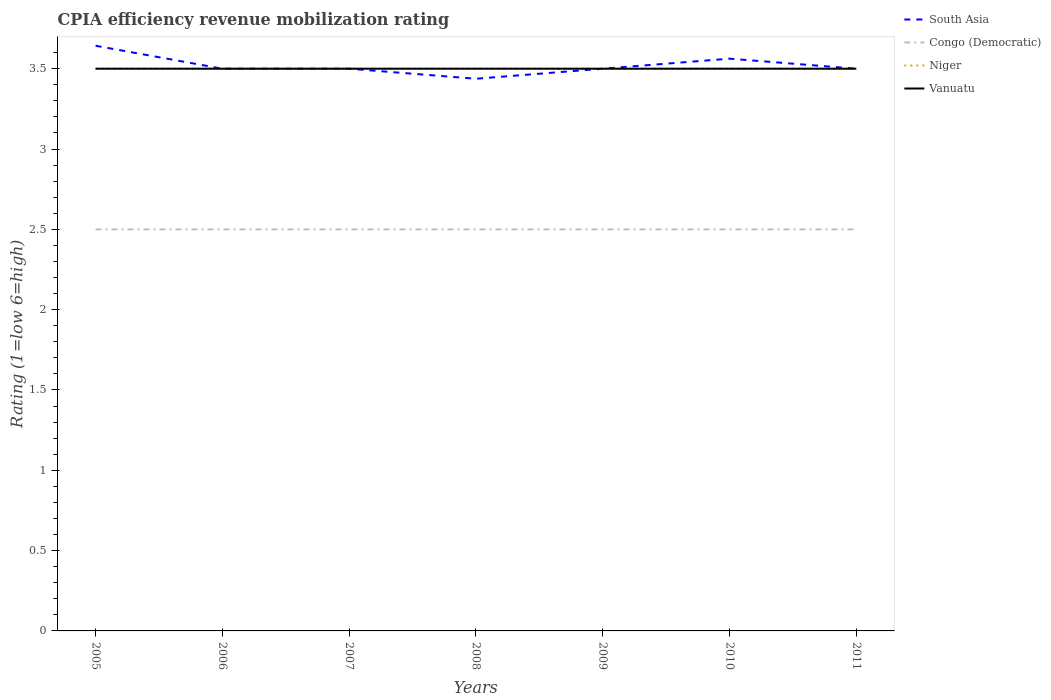How many different coloured lines are there?
Give a very brief answer. 4. Across all years, what is the maximum CPIA rating in Niger?
Ensure brevity in your answer.  3.5. In which year was the CPIA rating in South Asia maximum?
Offer a terse response. 2008. What is the total CPIA rating in Vanuatu in the graph?
Provide a succinct answer. 0. What is the difference between the highest and the second highest CPIA rating in South Asia?
Your response must be concise. 0.21. Is the CPIA rating in Niger strictly greater than the CPIA rating in South Asia over the years?
Give a very brief answer. No. How many years are there in the graph?
Keep it short and to the point. 7. Does the graph contain grids?
Your answer should be compact. No. Where does the legend appear in the graph?
Keep it short and to the point. Top right. How are the legend labels stacked?
Offer a terse response. Vertical. What is the title of the graph?
Offer a very short reply. CPIA efficiency revenue mobilization rating. Does "Azerbaijan" appear as one of the legend labels in the graph?
Provide a short and direct response. No. What is the label or title of the Y-axis?
Offer a very short reply. Rating (1=low 6=high). What is the Rating (1=low 6=high) in South Asia in 2005?
Your response must be concise. 3.64. What is the Rating (1=low 6=high) in Congo (Democratic) in 2005?
Your answer should be compact. 2.5. What is the Rating (1=low 6=high) in Niger in 2005?
Offer a terse response. 3.5. What is the Rating (1=low 6=high) in Congo (Democratic) in 2006?
Provide a short and direct response. 2.5. What is the Rating (1=low 6=high) of Niger in 2006?
Provide a succinct answer. 3.5. What is the Rating (1=low 6=high) in Congo (Democratic) in 2007?
Your answer should be very brief. 2.5. What is the Rating (1=low 6=high) in Niger in 2007?
Give a very brief answer. 3.5. What is the Rating (1=low 6=high) of Vanuatu in 2007?
Give a very brief answer. 3.5. What is the Rating (1=low 6=high) of South Asia in 2008?
Offer a terse response. 3.44. What is the Rating (1=low 6=high) of Congo (Democratic) in 2008?
Make the answer very short. 2.5. What is the Rating (1=low 6=high) of Vanuatu in 2008?
Your answer should be compact. 3.5. What is the Rating (1=low 6=high) of South Asia in 2009?
Your answer should be compact. 3.5. What is the Rating (1=low 6=high) in Congo (Democratic) in 2009?
Your answer should be very brief. 2.5. What is the Rating (1=low 6=high) of South Asia in 2010?
Give a very brief answer. 3.56. What is the Rating (1=low 6=high) in Vanuatu in 2010?
Give a very brief answer. 3.5. What is the Rating (1=low 6=high) in Niger in 2011?
Provide a short and direct response. 3.5. What is the Rating (1=low 6=high) in Vanuatu in 2011?
Offer a very short reply. 3.5. Across all years, what is the maximum Rating (1=low 6=high) in South Asia?
Give a very brief answer. 3.64. Across all years, what is the maximum Rating (1=low 6=high) in Vanuatu?
Your answer should be compact. 3.5. Across all years, what is the minimum Rating (1=low 6=high) of South Asia?
Your answer should be very brief. 3.44. Across all years, what is the minimum Rating (1=low 6=high) of Niger?
Keep it short and to the point. 3.5. Across all years, what is the minimum Rating (1=low 6=high) in Vanuatu?
Make the answer very short. 3.5. What is the total Rating (1=low 6=high) in South Asia in the graph?
Your answer should be compact. 24.64. What is the total Rating (1=low 6=high) in Congo (Democratic) in the graph?
Keep it short and to the point. 17.5. What is the total Rating (1=low 6=high) in Niger in the graph?
Offer a very short reply. 24.5. What is the difference between the Rating (1=low 6=high) of South Asia in 2005 and that in 2006?
Give a very brief answer. 0.14. What is the difference between the Rating (1=low 6=high) in Congo (Democratic) in 2005 and that in 2006?
Offer a very short reply. 0. What is the difference between the Rating (1=low 6=high) of Niger in 2005 and that in 2006?
Give a very brief answer. 0. What is the difference between the Rating (1=low 6=high) in Vanuatu in 2005 and that in 2006?
Your answer should be compact. 0. What is the difference between the Rating (1=low 6=high) in South Asia in 2005 and that in 2007?
Ensure brevity in your answer.  0.14. What is the difference between the Rating (1=low 6=high) in Congo (Democratic) in 2005 and that in 2007?
Offer a terse response. 0. What is the difference between the Rating (1=low 6=high) in Niger in 2005 and that in 2007?
Keep it short and to the point. 0. What is the difference between the Rating (1=low 6=high) in South Asia in 2005 and that in 2008?
Provide a succinct answer. 0.21. What is the difference between the Rating (1=low 6=high) in Niger in 2005 and that in 2008?
Offer a terse response. 0. What is the difference between the Rating (1=low 6=high) of Vanuatu in 2005 and that in 2008?
Provide a short and direct response. 0. What is the difference between the Rating (1=low 6=high) in South Asia in 2005 and that in 2009?
Your response must be concise. 0.14. What is the difference between the Rating (1=low 6=high) in Congo (Democratic) in 2005 and that in 2009?
Keep it short and to the point. 0. What is the difference between the Rating (1=low 6=high) in South Asia in 2005 and that in 2010?
Provide a succinct answer. 0.08. What is the difference between the Rating (1=low 6=high) in Congo (Democratic) in 2005 and that in 2010?
Offer a terse response. 0. What is the difference between the Rating (1=low 6=high) of South Asia in 2005 and that in 2011?
Give a very brief answer. 0.14. What is the difference between the Rating (1=low 6=high) in Niger in 2005 and that in 2011?
Your response must be concise. 0. What is the difference between the Rating (1=low 6=high) of Vanuatu in 2005 and that in 2011?
Offer a very short reply. 0. What is the difference between the Rating (1=low 6=high) of Congo (Democratic) in 2006 and that in 2007?
Keep it short and to the point. 0. What is the difference between the Rating (1=low 6=high) of Vanuatu in 2006 and that in 2007?
Your answer should be very brief. 0. What is the difference between the Rating (1=low 6=high) of South Asia in 2006 and that in 2008?
Your response must be concise. 0.06. What is the difference between the Rating (1=low 6=high) of Congo (Democratic) in 2006 and that in 2008?
Keep it short and to the point. 0. What is the difference between the Rating (1=low 6=high) in Niger in 2006 and that in 2008?
Make the answer very short. 0. What is the difference between the Rating (1=low 6=high) in South Asia in 2006 and that in 2009?
Offer a very short reply. 0. What is the difference between the Rating (1=low 6=high) of Congo (Democratic) in 2006 and that in 2009?
Give a very brief answer. 0. What is the difference between the Rating (1=low 6=high) in Niger in 2006 and that in 2009?
Offer a very short reply. 0. What is the difference between the Rating (1=low 6=high) of South Asia in 2006 and that in 2010?
Offer a very short reply. -0.06. What is the difference between the Rating (1=low 6=high) of Congo (Democratic) in 2006 and that in 2010?
Your response must be concise. 0. What is the difference between the Rating (1=low 6=high) in Congo (Democratic) in 2006 and that in 2011?
Your answer should be very brief. 0. What is the difference between the Rating (1=low 6=high) of South Asia in 2007 and that in 2008?
Give a very brief answer. 0.06. What is the difference between the Rating (1=low 6=high) of Congo (Democratic) in 2007 and that in 2008?
Provide a short and direct response. 0. What is the difference between the Rating (1=low 6=high) in Vanuatu in 2007 and that in 2008?
Offer a terse response. 0. What is the difference between the Rating (1=low 6=high) in South Asia in 2007 and that in 2009?
Your answer should be compact. 0. What is the difference between the Rating (1=low 6=high) of Congo (Democratic) in 2007 and that in 2009?
Your answer should be compact. 0. What is the difference between the Rating (1=low 6=high) in Vanuatu in 2007 and that in 2009?
Provide a short and direct response. 0. What is the difference between the Rating (1=low 6=high) in South Asia in 2007 and that in 2010?
Your response must be concise. -0.06. What is the difference between the Rating (1=low 6=high) in Niger in 2007 and that in 2010?
Your answer should be compact. 0. What is the difference between the Rating (1=low 6=high) in Vanuatu in 2007 and that in 2010?
Ensure brevity in your answer.  0. What is the difference between the Rating (1=low 6=high) in Niger in 2007 and that in 2011?
Offer a terse response. 0. What is the difference between the Rating (1=low 6=high) in South Asia in 2008 and that in 2009?
Provide a succinct answer. -0.06. What is the difference between the Rating (1=low 6=high) in Congo (Democratic) in 2008 and that in 2009?
Make the answer very short. 0. What is the difference between the Rating (1=low 6=high) in Niger in 2008 and that in 2009?
Make the answer very short. 0. What is the difference between the Rating (1=low 6=high) in South Asia in 2008 and that in 2010?
Ensure brevity in your answer.  -0.12. What is the difference between the Rating (1=low 6=high) in Congo (Democratic) in 2008 and that in 2010?
Provide a succinct answer. 0. What is the difference between the Rating (1=low 6=high) of Vanuatu in 2008 and that in 2010?
Your response must be concise. 0. What is the difference between the Rating (1=low 6=high) in South Asia in 2008 and that in 2011?
Your answer should be very brief. -0.06. What is the difference between the Rating (1=low 6=high) in South Asia in 2009 and that in 2010?
Your answer should be very brief. -0.06. What is the difference between the Rating (1=low 6=high) in Niger in 2009 and that in 2010?
Make the answer very short. 0. What is the difference between the Rating (1=low 6=high) in Congo (Democratic) in 2009 and that in 2011?
Ensure brevity in your answer.  0. What is the difference between the Rating (1=low 6=high) in South Asia in 2010 and that in 2011?
Your response must be concise. 0.06. What is the difference between the Rating (1=low 6=high) of Congo (Democratic) in 2010 and that in 2011?
Your response must be concise. 0. What is the difference between the Rating (1=low 6=high) of South Asia in 2005 and the Rating (1=low 6=high) of Congo (Democratic) in 2006?
Ensure brevity in your answer.  1.14. What is the difference between the Rating (1=low 6=high) in South Asia in 2005 and the Rating (1=low 6=high) in Niger in 2006?
Your answer should be compact. 0.14. What is the difference between the Rating (1=low 6=high) in South Asia in 2005 and the Rating (1=low 6=high) in Vanuatu in 2006?
Make the answer very short. 0.14. What is the difference between the Rating (1=low 6=high) of Congo (Democratic) in 2005 and the Rating (1=low 6=high) of Vanuatu in 2006?
Your response must be concise. -1. What is the difference between the Rating (1=low 6=high) of Niger in 2005 and the Rating (1=low 6=high) of Vanuatu in 2006?
Your answer should be very brief. 0. What is the difference between the Rating (1=low 6=high) of South Asia in 2005 and the Rating (1=low 6=high) of Congo (Democratic) in 2007?
Make the answer very short. 1.14. What is the difference between the Rating (1=low 6=high) in South Asia in 2005 and the Rating (1=low 6=high) in Niger in 2007?
Offer a very short reply. 0.14. What is the difference between the Rating (1=low 6=high) of South Asia in 2005 and the Rating (1=low 6=high) of Vanuatu in 2007?
Make the answer very short. 0.14. What is the difference between the Rating (1=low 6=high) in Congo (Democratic) in 2005 and the Rating (1=low 6=high) in Niger in 2007?
Provide a short and direct response. -1. What is the difference between the Rating (1=low 6=high) of Congo (Democratic) in 2005 and the Rating (1=low 6=high) of Vanuatu in 2007?
Offer a very short reply. -1. What is the difference between the Rating (1=low 6=high) of Niger in 2005 and the Rating (1=low 6=high) of Vanuatu in 2007?
Make the answer very short. 0. What is the difference between the Rating (1=low 6=high) of South Asia in 2005 and the Rating (1=low 6=high) of Niger in 2008?
Provide a succinct answer. 0.14. What is the difference between the Rating (1=low 6=high) of South Asia in 2005 and the Rating (1=low 6=high) of Vanuatu in 2008?
Provide a succinct answer. 0.14. What is the difference between the Rating (1=low 6=high) in Congo (Democratic) in 2005 and the Rating (1=low 6=high) in Niger in 2008?
Make the answer very short. -1. What is the difference between the Rating (1=low 6=high) in Congo (Democratic) in 2005 and the Rating (1=low 6=high) in Vanuatu in 2008?
Keep it short and to the point. -1. What is the difference between the Rating (1=low 6=high) in South Asia in 2005 and the Rating (1=low 6=high) in Niger in 2009?
Your answer should be very brief. 0.14. What is the difference between the Rating (1=low 6=high) in South Asia in 2005 and the Rating (1=low 6=high) in Vanuatu in 2009?
Your answer should be compact. 0.14. What is the difference between the Rating (1=low 6=high) in Congo (Democratic) in 2005 and the Rating (1=low 6=high) in Niger in 2009?
Give a very brief answer. -1. What is the difference between the Rating (1=low 6=high) in Congo (Democratic) in 2005 and the Rating (1=low 6=high) in Vanuatu in 2009?
Give a very brief answer. -1. What is the difference between the Rating (1=low 6=high) in Niger in 2005 and the Rating (1=low 6=high) in Vanuatu in 2009?
Ensure brevity in your answer.  0. What is the difference between the Rating (1=low 6=high) in South Asia in 2005 and the Rating (1=low 6=high) in Niger in 2010?
Provide a short and direct response. 0.14. What is the difference between the Rating (1=low 6=high) of South Asia in 2005 and the Rating (1=low 6=high) of Vanuatu in 2010?
Make the answer very short. 0.14. What is the difference between the Rating (1=low 6=high) in Congo (Democratic) in 2005 and the Rating (1=low 6=high) in Niger in 2010?
Provide a succinct answer. -1. What is the difference between the Rating (1=low 6=high) of Congo (Democratic) in 2005 and the Rating (1=low 6=high) of Vanuatu in 2010?
Your answer should be very brief. -1. What is the difference between the Rating (1=low 6=high) in South Asia in 2005 and the Rating (1=low 6=high) in Congo (Democratic) in 2011?
Your answer should be very brief. 1.14. What is the difference between the Rating (1=low 6=high) in South Asia in 2005 and the Rating (1=low 6=high) in Niger in 2011?
Offer a terse response. 0.14. What is the difference between the Rating (1=low 6=high) of South Asia in 2005 and the Rating (1=low 6=high) of Vanuatu in 2011?
Your answer should be very brief. 0.14. What is the difference between the Rating (1=low 6=high) of South Asia in 2006 and the Rating (1=low 6=high) of Congo (Democratic) in 2007?
Make the answer very short. 1. What is the difference between the Rating (1=low 6=high) in Congo (Democratic) in 2006 and the Rating (1=low 6=high) in Niger in 2007?
Provide a succinct answer. -1. What is the difference between the Rating (1=low 6=high) in South Asia in 2006 and the Rating (1=low 6=high) in Congo (Democratic) in 2008?
Your answer should be compact. 1. What is the difference between the Rating (1=low 6=high) of South Asia in 2006 and the Rating (1=low 6=high) of Niger in 2008?
Make the answer very short. 0. What is the difference between the Rating (1=low 6=high) of South Asia in 2006 and the Rating (1=low 6=high) of Vanuatu in 2008?
Make the answer very short. 0. What is the difference between the Rating (1=low 6=high) in Congo (Democratic) in 2006 and the Rating (1=low 6=high) in Vanuatu in 2008?
Make the answer very short. -1. What is the difference between the Rating (1=low 6=high) of Niger in 2006 and the Rating (1=low 6=high) of Vanuatu in 2008?
Your answer should be compact. 0. What is the difference between the Rating (1=low 6=high) of South Asia in 2006 and the Rating (1=low 6=high) of Niger in 2009?
Provide a succinct answer. 0. What is the difference between the Rating (1=low 6=high) in South Asia in 2006 and the Rating (1=low 6=high) in Congo (Democratic) in 2010?
Provide a succinct answer. 1. What is the difference between the Rating (1=low 6=high) of Congo (Democratic) in 2006 and the Rating (1=low 6=high) of Niger in 2010?
Your answer should be very brief. -1. What is the difference between the Rating (1=low 6=high) of Congo (Democratic) in 2006 and the Rating (1=low 6=high) of Vanuatu in 2010?
Give a very brief answer. -1. What is the difference between the Rating (1=low 6=high) in South Asia in 2006 and the Rating (1=low 6=high) in Congo (Democratic) in 2011?
Make the answer very short. 1. What is the difference between the Rating (1=low 6=high) in South Asia in 2006 and the Rating (1=low 6=high) in Niger in 2011?
Make the answer very short. 0. What is the difference between the Rating (1=low 6=high) in South Asia in 2006 and the Rating (1=low 6=high) in Vanuatu in 2011?
Your answer should be very brief. 0. What is the difference between the Rating (1=low 6=high) in Congo (Democratic) in 2006 and the Rating (1=low 6=high) in Vanuatu in 2011?
Provide a short and direct response. -1. What is the difference between the Rating (1=low 6=high) in Niger in 2006 and the Rating (1=low 6=high) in Vanuatu in 2011?
Your answer should be very brief. 0. What is the difference between the Rating (1=low 6=high) of South Asia in 2007 and the Rating (1=low 6=high) of Congo (Democratic) in 2008?
Offer a terse response. 1. What is the difference between the Rating (1=low 6=high) in South Asia in 2007 and the Rating (1=low 6=high) in Niger in 2008?
Your answer should be compact. 0. What is the difference between the Rating (1=low 6=high) of Congo (Democratic) in 2007 and the Rating (1=low 6=high) of Niger in 2008?
Make the answer very short. -1. What is the difference between the Rating (1=low 6=high) in Congo (Democratic) in 2007 and the Rating (1=low 6=high) in Vanuatu in 2008?
Keep it short and to the point. -1. What is the difference between the Rating (1=low 6=high) of South Asia in 2007 and the Rating (1=low 6=high) of Vanuatu in 2009?
Offer a terse response. 0. What is the difference between the Rating (1=low 6=high) of Congo (Democratic) in 2007 and the Rating (1=low 6=high) of Niger in 2009?
Keep it short and to the point. -1. What is the difference between the Rating (1=low 6=high) in South Asia in 2007 and the Rating (1=low 6=high) in Niger in 2010?
Offer a terse response. 0. What is the difference between the Rating (1=low 6=high) in Congo (Democratic) in 2007 and the Rating (1=low 6=high) in Niger in 2010?
Ensure brevity in your answer.  -1. What is the difference between the Rating (1=low 6=high) in South Asia in 2007 and the Rating (1=low 6=high) in Congo (Democratic) in 2011?
Provide a short and direct response. 1. What is the difference between the Rating (1=low 6=high) of South Asia in 2007 and the Rating (1=low 6=high) of Niger in 2011?
Make the answer very short. 0. What is the difference between the Rating (1=low 6=high) in South Asia in 2007 and the Rating (1=low 6=high) in Vanuatu in 2011?
Offer a terse response. 0. What is the difference between the Rating (1=low 6=high) of South Asia in 2008 and the Rating (1=low 6=high) of Congo (Democratic) in 2009?
Give a very brief answer. 0.94. What is the difference between the Rating (1=low 6=high) in South Asia in 2008 and the Rating (1=low 6=high) in Niger in 2009?
Make the answer very short. -0.06. What is the difference between the Rating (1=low 6=high) of South Asia in 2008 and the Rating (1=low 6=high) of Vanuatu in 2009?
Your answer should be compact. -0.06. What is the difference between the Rating (1=low 6=high) in Congo (Democratic) in 2008 and the Rating (1=low 6=high) in Vanuatu in 2009?
Provide a short and direct response. -1. What is the difference between the Rating (1=low 6=high) in Niger in 2008 and the Rating (1=low 6=high) in Vanuatu in 2009?
Keep it short and to the point. 0. What is the difference between the Rating (1=low 6=high) in South Asia in 2008 and the Rating (1=low 6=high) in Niger in 2010?
Your answer should be very brief. -0.06. What is the difference between the Rating (1=low 6=high) of South Asia in 2008 and the Rating (1=low 6=high) of Vanuatu in 2010?
Your answer should be compact. -0.06. What is the difference between the Rating (1=low 6=high) in Congo (Democratic) in 2008 and the Rating (1=low 6=high) in Vanuatu in 2010?
Provide a succinct answer. -1. What is the difference between the Rating (1=low 6=high) in Niger in 2008 and the Rating (1=low 6=high) in Vanuatu in 2010?
Make the answer very short. 0. What is the difference between the Rating (1=low 6=high) in South Asia in 2008 and the Rating (1=low 6=high) in Congo (Democratic) in 2011?
Give a very brief answer. 0.94. What is the difference between the Rating (1=low 6=high) in South Asia in 2008 and the Rating (1=low 6=high) in Niger in 2011?
Your answer should be very brief. -0.06. What is the difference between the Rating (1=low 6=high) in South Asia in 2008 and the Rating (1=low 6=high) in Vanuatu in 2011?
Offer a terse response. -0.06. What is the difference between the Rating (1=low 6=high) in Congo (Democratic) in 2008 and the Rating (1=low 6=high) in Niger in 2011?
Offer a very short reply. -1. What is the difference between the Rating (1=low 6=high) of Niger in 2008 and the Rating (1=low 6=high) of Vanuatu in 2011?
Keep it short and to the point. 0. What is the difference between the Rating (1=low 6=high) in Congo (Democratic) in 2009 and the Rating (1=low 6=high) in Niger in 2010?
Your answer should be compact. -1. What is the difference between the Rating (1=low 6=high) in Niger in 2009 and the Rating (1=low 6=high) in Vanuatu in 2011?
Your answer should be very brief. 0. What is the difference between the Rating (1=low 6=high) of South Asia in 2010 and the Rating (1=low 6=high) of Niger in 2011?
Give a very brief answer. 0.06. What is the difference between the Rating (1=low 6=high) of South Asia in 2010 and the Rating (1=low 6=high) of Vanuatu in 2011?
Provide a succinct answer. 0.06. What is the average Rating (1=low 6=high) of South Asia per year?
Your answer should be compact. 3.52. What is the average Rating (1=low 6=high) of Congo (Democratic) per year?
Your response must be concise. 2.5. In the year 2005, what is the difference between the Rating (1=low 6=high) in South Asia and Rating (1=low 6=high) in Congo (Democratic)?
Keep it short and to the point. 1.14. In the year 2005, what is the difference between the Rating (1=low 6=high) in South Asia and Rating (1=low 6=high) in Niger?
Your response must be concise. 0.14. In the year 2005, what is the difference between the Rating (1=low 6=high) of South Asia and Rating (1=low 6=high) of Vanuatu?
Your response must be concise. 0.14. In the year 2005, what is the difference between the Rating (1=low 6=high) of Congo (Democratic) and Rating (1=low 6=high) of Niger?
Provide a short and direct response. -1. In the year 2005, what is the difference between the Rating (1=low 6=high) of Congo (Democratic) and Rating (1=low 6=high) of Vanuatu?
Offer a very short reply. -1. In the year 2005, what is the difference between the Rating (1=low 6=high) of Niger and Rating (1=low 6=high) of Vanuatu?
Ensure brevity in your answer.  0. In the year 2006, what is the difference between the Rating (1=low 6=high) in South Asia and Rating (1=low 6=high) in Niger?
Make the answer very short. 0. In the year 2006, what is the difference between the Rating (1=low 6=high) of Congo (Democratic) and Rating (1=low 6=high) of Niger?
Your answer should be very brief. -1. In the year 2006, what is the difference between the Rating (1=low 6=high) in Niger and Rating (1=low 6=high) in Vanuatu?
Offer a very short reply. 0. In the year 2007, what is the difference between the Rating (1=low 6=high) in South Asia and Rating (1=low 6=high) in Niger?
Keep it short and to the point. 0. In the year 2007, what is the difference between the Rating (1=low 6=high) in South Asia and Rating (1=low 6=high) in Vanuatu?
Ensure brevity in your answer.  0. In the year 2007, what is the difference between the Rating (1=low 6=high) of Congo (Democratic) and Rating (1=low 6=high) of Niger?
Your response must be concise. -1. In the year 2008, what is the difference between the Rating (1=low 6=high) in South Asia and Rating (1=low 6=high) in Niger?
Your answer should be compact. -0.06. In the year 2008, what is the difference between the Rating (1=low 6=high) of South Asia and Rating (1=low 6=high) of Vanuatu?
Keep it short and to the point. -0.06. In the year 2008, what is the difference between the Rating (1=low 6=high) in Congo (Democratic) and Rating (1=low 6=high) in Niger?
Keep it short and to the point. -1. In the year 2008, what is the difference between the Rating (1=low 6=high) in Congo (Democratic) and Rating (1=low 6=high) in Vanuatu?
Keep it short and to the point. -1. In the year 2008, what is the difference between the Rating (1=low 6=high) of Niger and Rating (1=low 6=high) of Vanuatu?
Keep it short and to the point. 0. In the year 2009, what is the difference between the Rating (1=low 6=high) of South Asia and Rating (1=low 6=high) of Congo (Democratic)?
Provide a succinct answer. 1. In the year 2009, what is the difference between the Rating (1=low 6=high) of Congo (Democratic) and Rating (1=low 6=high) of Vanuatu?
Keep it short and to the point. -1. In the year 2010, what is the difference between the Rating (1=low 6=high) of South Asia and Rating (1=low 6=high) of Niger?
Provide a short and direct response. 0.06. In the year 2010, what is the difference between the Rating (1=low 6=high) in South Asia and Rating (1=low 6=high) in Vanuatu?
Your response must be concise. 0.06. In the year 2010, what is the difference between the Rating (1=low 6=high) in Congo (Democratic) and Rating (1=low 6=high) in Niger?
Your response must be concise. -1. In the year 2010, what is the difference between the Rating (1=low 6=high) of Niger and Rating (1=low 6=high) of Vanuatu?
Offer a terse response. 0. In the year 2011, what is the difference between the Rating (1=low 6=high) of South Asia and Rating (1=low 6=high) of Congo (Democratic)?
Ensure brevity in your answer.  1. In the year 2011, what is the difference between the Rating (1=low 6=high) in South Asia and Rating (1=low 6=high) in Niger?
Offer a terse response. 0. In the year 2011, what is the difference between the Rating (1=low 6=high) in Niger and Rating (1=low 6=high) in Vanuatu?
Give a very brief answer. 0. What is the ratio of the Rating (1=low 6=high) in South Asia in 2005 to that in 2006?
Offer a terse response. 1.04. What is the ratio of the Rating (1=low 6=high) in Congo (Democratic) in 2005 to that in 2006?
Your response must be concise. 1. What is the ratio of the Rating (1=low 6=high) of Niger in 2005 to that in 2006?
Offer a terse response. 1. What is the ratio of the Rating (1=low 6=high) of Vanuatu in 2005 to that in 2006?
Provide a short and direct response. 1. What is the ratio of the Rating (1=low 6=high) of South Asia in 2005 to that in 2007?
Offer a very short reply. 1.04. What is the ratio of the Rating (1=low 6=high) in South Asia in 2005 to that in 2008?
Keep it short and to the point. 1.06. What is the ratio of the Rating (1=low 6=high) in Congo (Democratic) in 2005 to that in 2008?
Your response must be concise. 1. What is the ratio of the Rating (1=low 6=high) of South Asia in 2005 to that in 2009?
Give a very brief answer. 1.04. What is the ratio of the Rating (1=low 6=high) in South Asia in 2005 to that in 2010?
Keep it short and to the point. 1.02. What is the ratio of the Rating (1=low 6=high) of Congo (Democratic) in 2005 to that in 2010?
Offer a terse response. 1. What is the ratio of the Rating (1=low 6=high) in Niger in 2005 to that in 2010?
Provide a short and direct response. 1. What is the ratio of the Rating (1=low 6=high) in Vanuatu in 2005 to that in 2010?
Provide a succinct answer. 1. What is the ratio of the Rating (1=low 6=high) in South Asia in 2005 to that in 2011?
Your answer should be compact. 1.04. What is the ratio of the Rating (1=low 6=high) in Congo (Democratic) in 2005 to that in 2011?
Keep it short and to the point. 1. What is the ratio of the Rating (1=low 6=high) of Vanuatu in 2005 to that in 2011?
Your response must be concise. 1. What is the ratio of the Rating (1=low 6=high) of South Asia in 2006 to that in 2007?
Offer a terse response. 1. What is the ratio of the Rating (1=low 6=high) of Congo (Democratic) in 2006 to that in 2007?
Provide a succinct answer. 1. What is the ratio of the Rating (1=low 6=high) in Niger in 2006 to that in 2007?
Offer a terse response. 1. What is the ratio of the Rating (1=low 6=high) in South Asia in 2006 to that in 2008?
Your answer should be very brief. 1.02. What is the ratio of the Rating (1=low 6=high) of Niger in 2006 to that in 2008?
Give a very brief answer. 1. What is the ratio of the Rating (1=low 6=high) in South Asia in 2006 to that in 2009?
Offer a terse response. 1. What is the ratio of the Rating (1=low 6=high) of Vanuatu in 2006 to that in 2009?
Provide a short and direct response. 1. What is the ratio of the Rating (1=low 6=high) of South Asia in 2006 to that in 2010?
Provide a succinct answer. 0.98. What is the ratio of the Rating (1=low 6=high) in Vanuatu in 2006 to that in 2010?
Offer a terse response. 1. What is the ratio of the Rating (1=low 6=high) in South Asia in 2006 to that in 2011?
Make the answer very short. 1. What is the ratio of the Rating (1=low 6=high) of Niger in 2006 to that in 2011?
Your answer should be very brief. 1. What is the ratio of the Rating (1=low 6=high) of Vanuatu in 2006 to that in 2011?
Offer a terse response. 1. What is the ratio of the Rating (1=low 6=high) in South Asia in 2007 to that in 2008?
Ensure brevity in your answer.  1.02. What is the ratio of the Rating (1=low 6=high) of Congo (Democratic) in 2007 to that in 2008?
Give a very brief answer. 1. What is the ratio of the Rating (1=low 6=high) of South Asia in 2007 to that in 2009?
Offer a very short reply. 1. What is the ratio of the Rating (1=low 6=high) of Congo (Democratic) in 2007 to that in 2009?
Offer a very short reply. 1. What is the ratio of the Rating (1=low 6=high) in South Asia in 2007 to that in 2010?
Your answer should be very brief. 0.98. What is the ratio of the Rating (1=low 6=high) of Congo (Democratic) in 2007 to that in 2010?
Your response must be concise. 1. What is the ratio of the Rating (1=low 6=high) of Niger in 2007 to that in 2011?
Keep it short and to the point. 1. What is the ratio of the Rating (1=low 6=high) of Vanuatu in 2007 to that in 2011?
Your answer should be very brief. 1. What is the ratio of the Rating (1=low 6=high) of South Asia in 2008 to that in 2009?
Make the answer very short. 0.98. What is the ratio of the Rating (1=low 6=high) of Congo (Democratic) in 2008 to that in 2009?
Ensure brevity in your answer.  1. What is the ratio of the Rating (1=low 6=high) of Niger in 2008 to that in 2009?
Give a very brief answer. 1. What is the ratio of the Rating (1=low 6=high) in South Asia in 2008 to that in 2010?
Your response must be concise. 0.96. What is the ratio of the Rating (1=low 6=high) of South Asia in 2008 to that in 2011?
Provide a short and direct response. 0.98. What is the ratio of the Rating (1=low 6=high) of Congo (Democratic) in 2008 to that in 2011?
Make the answer very short. 1. What is the ratio of the Rating (1=low 6=high) in Niger in 2008 to that in 2011?
Offer a very short reply. 1. What is the ratio of the Rating (1=low 6=high) in South Asia in 2009 to that in 2010?
Offer a very short reply. 0.98. What is the ratio of the Rating (1=low 6=high) in Vanuatu in 2009 to that in 2010?
Your answer should be very brief. 1. What is the ratio of the Rating (1=low 6=high) in South Asia in 2009 to that in 2011?
Offer a very short reply. 1. What is the ratio of the Rating (1=low 6=high) in Congo (Democratic) in 2009 to that in 2011?
Your answer should be compact. 1. What is the ratio of the Rating (1=low 6=high) of Niger in 2009 to that in 2011?
Offer a terse response. 1. What is the ratio of the Rating (1=low 6=high) of Vanuatu in 2009 to that in 2011?
Keep it short and to the point. 1. What is the ratio of the Rating (1=low 6=high) in South Asia in 2010 to that in 2011?
Provide a succinct answer. 1.02. What is the ratio of the Rating (1=low 6=high) of Vanuatu in 2010 to that in 2011?
Provide a succinct answer. 1. What is the difference between the highest and the second highest Rating (1=low 6=high) in South Asia?
Give a very brief answer. 0.08. What is the difference between the highest and the lowest Rating (1=low 6=high) in South Asia?
Your answer should be compact. 0.21. 